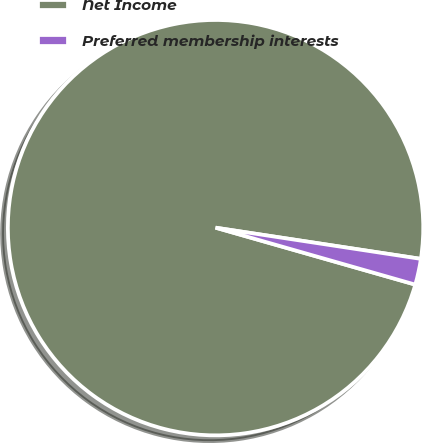Convert chart. <chart><loc_0><loc_0><loc_500><loc_500><pie_chart><fcel>Net Income<fcel>Preferred membership interests<nl><fcel>97.98%<fcel>2.02%<nl></chart> 